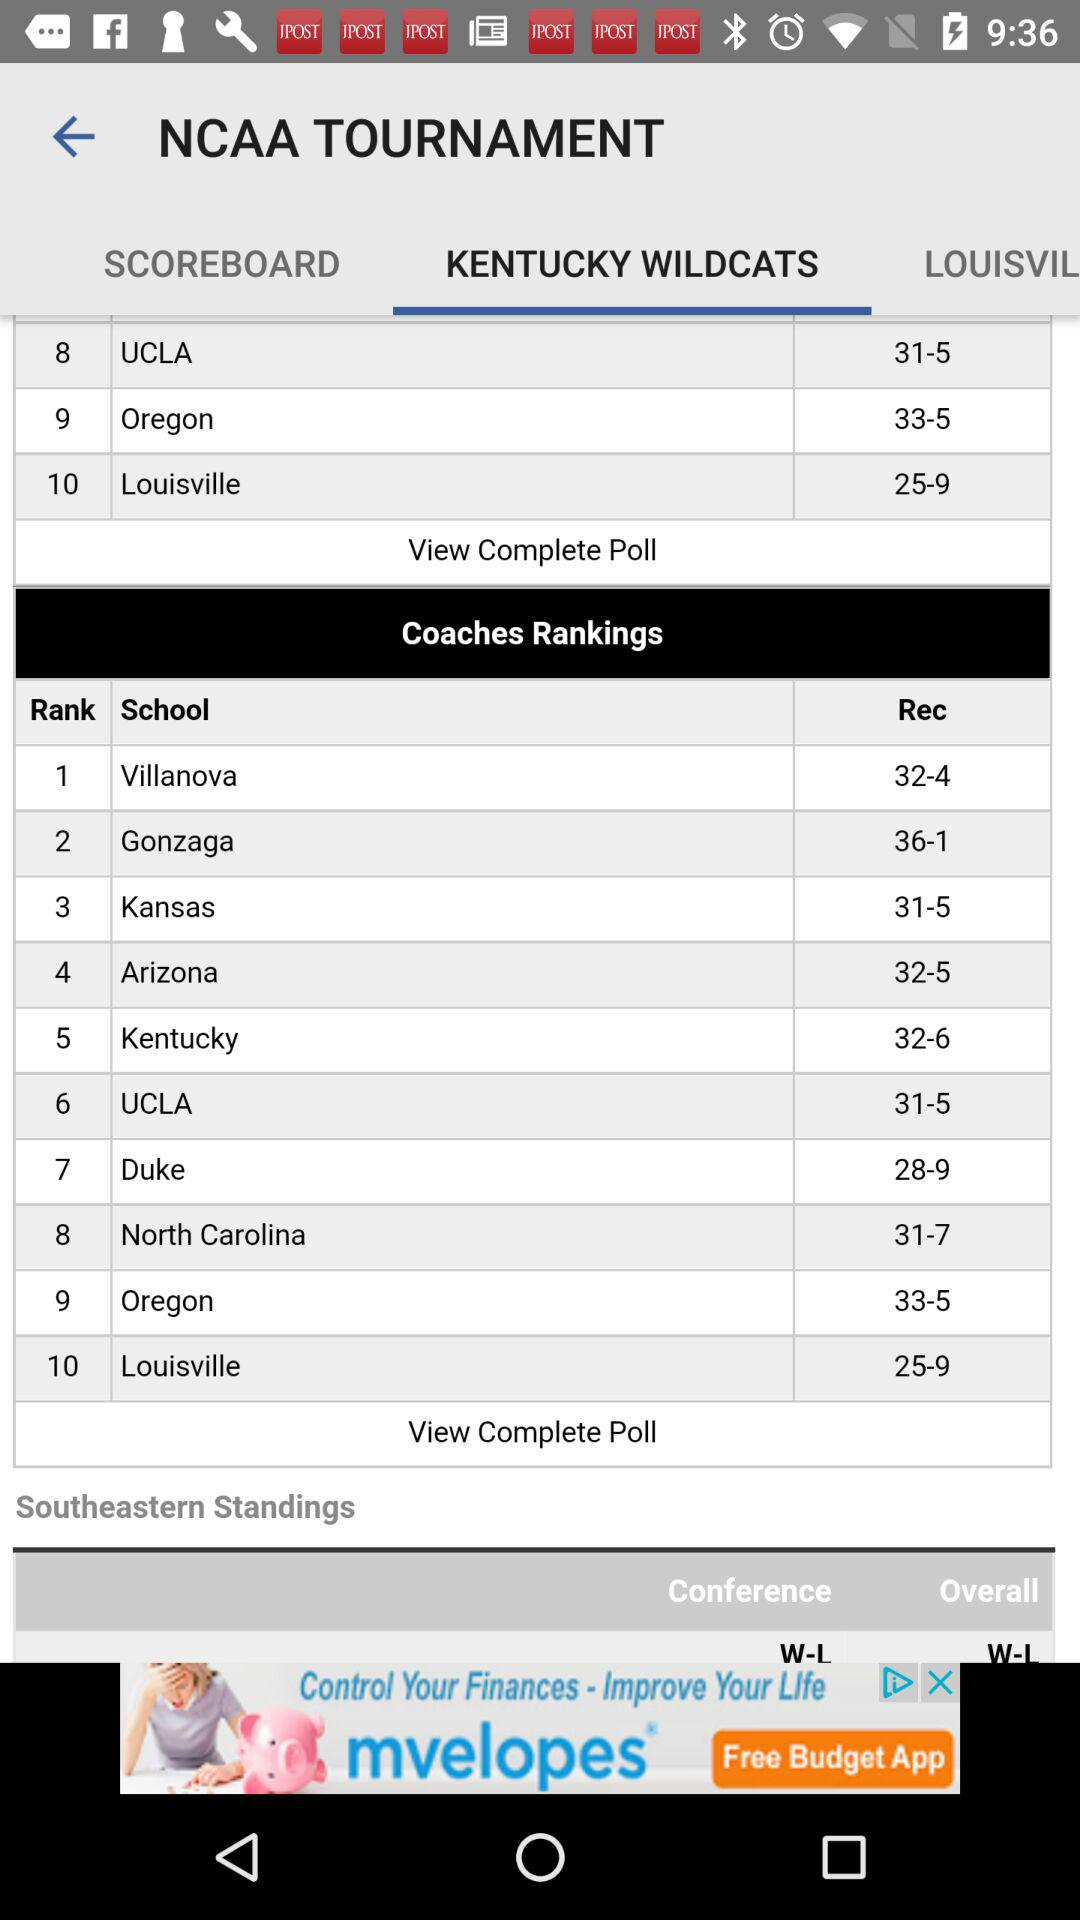What is the record for "Oregon"? The record for "Oregon" is 33-5. 